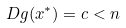Convert formula to latex. <formula><loc_0><loc_0><loc_500><loc_500>D g ( x ^ { * } ) = c < n</formula> 